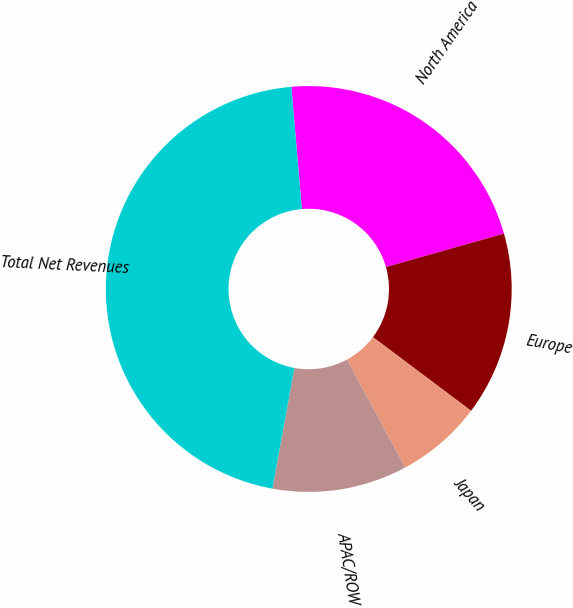<chart> <loc_0><loc_0><loc_500><loc_500><pie_chart><fcel>North America<fcel>Europe<fcel>Japan<fcel>APAC/ROW<fcel>Total Net Revenues<nl><fcel>21.97%<fcel>14.65%<fcel>6.86%<fcel>10.76%<fcel>45.77%<nl></chart> 